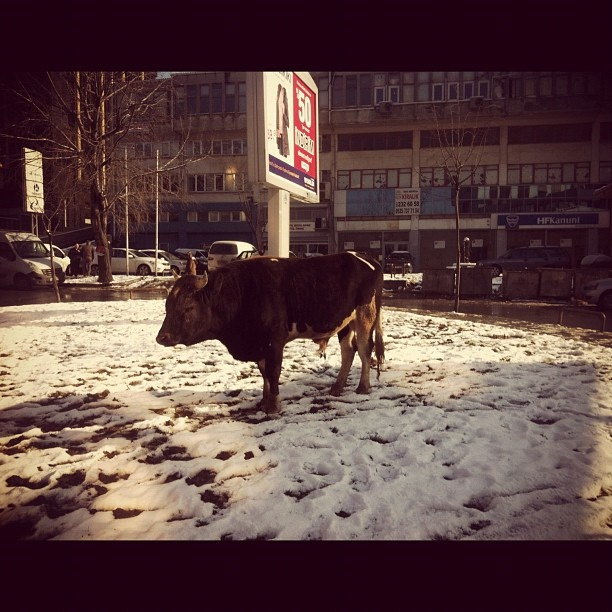Describe the objects in this image and their specific colors. I can see cow in black, maroon, brown, and gray tones, car in black, maroon, brown, and gray tones, car in black, brown, and purple tones, car in black, brown, gray, and maroon tones, and car in black, maroon, lightyellow, and brown tones in this image. 